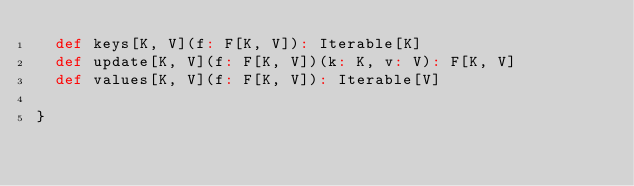Convert code to text. <code><loc_0><loc_0><loc_500><loc_500><_Scala_>  def keys[K, V](f: F[K, V]): Iterable[K]
  def update[K, V](f: F[K, V])(k: K, v: V): F[K, V]
  def values[K, V](f: F[K, V]): Iterable[V]

}
</code> 